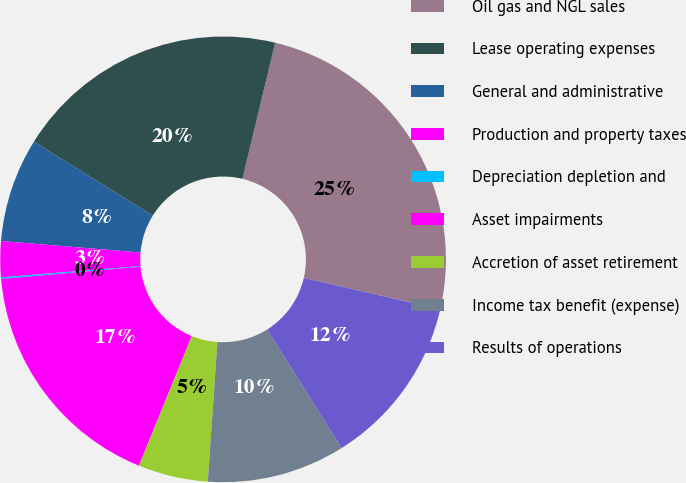Convert chart. <chart><loc_0><loc_0><loc_500><loc_500><pie_chart><fcel>Oil gas and NGL sales<fcel>Lease operating expenses<fcel>General and administrative<fcel>Production and property taxes<fcel>Depreciation depletion and<fcel>Asset impairments<fcel>Accretion of asset retirement<fcel>Income tax benefit (expense)<fcel>Results of operations<nl><fcel>24.84%<fcel>19.9%<fcel>7.54%<fcel>2.6%<fcel>0.12%<fcel>17.43%<fcel>5.07%<fcel>10.01%<fcel>12.48%<nl></chart> 